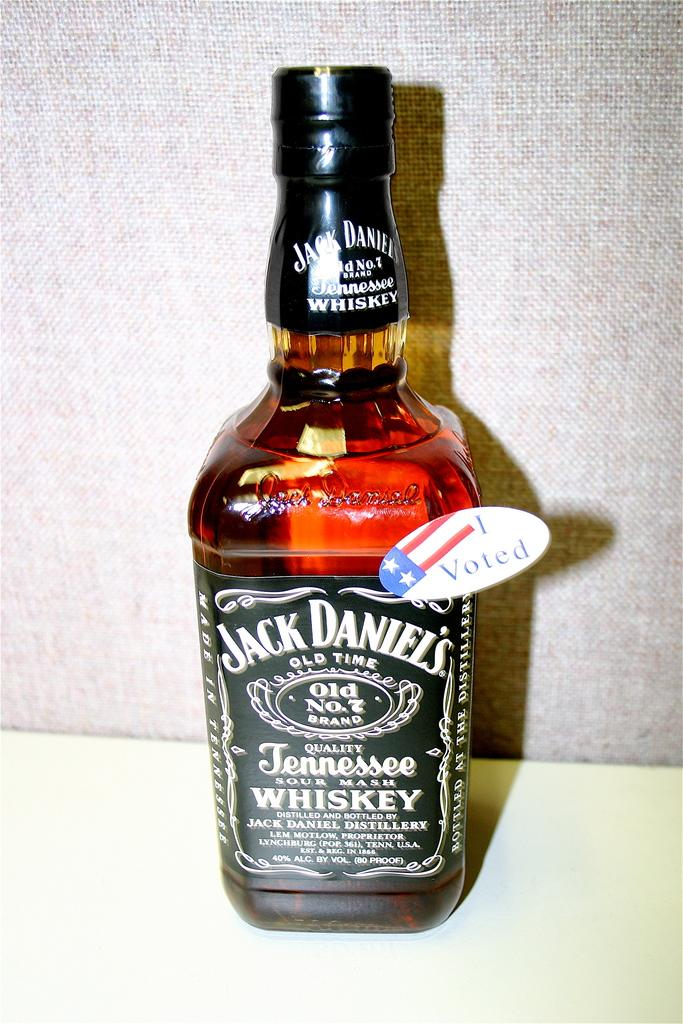Provide a one-sentence caption for the provided image. i voted sticker attached to bottle of jack daniels tennessee whiskey. 